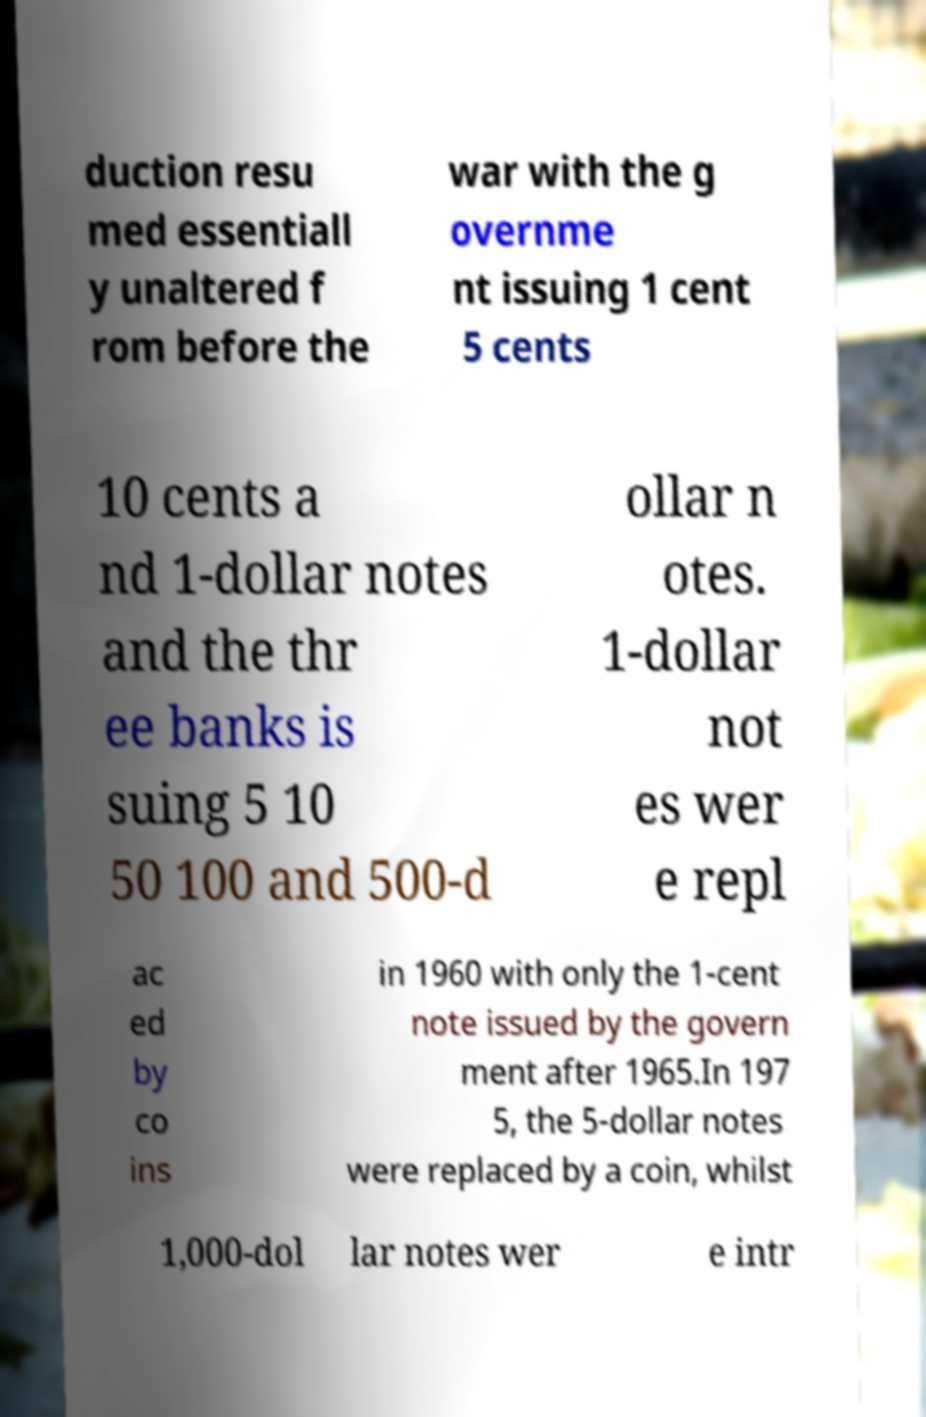What messages or text are displayed in this image? I need them in a readable, typed format. duction resu med essentiall y unaltered f rom before the war with the g overnme nt issuing 1 cent 5 cents 10 cents a nd 1-dollar notes and the thr ee banks is suing 5 10 50 100 and 500-d ollar n otes. 1-dollar not es wer e repl ac ed by co ins in 1960 with only the 1-cent note issued by the govern ment after 1965.In 197 5, the 5-dollar notes were replaced by a coin, whilst 1,000-dol lar notes wer e intr 